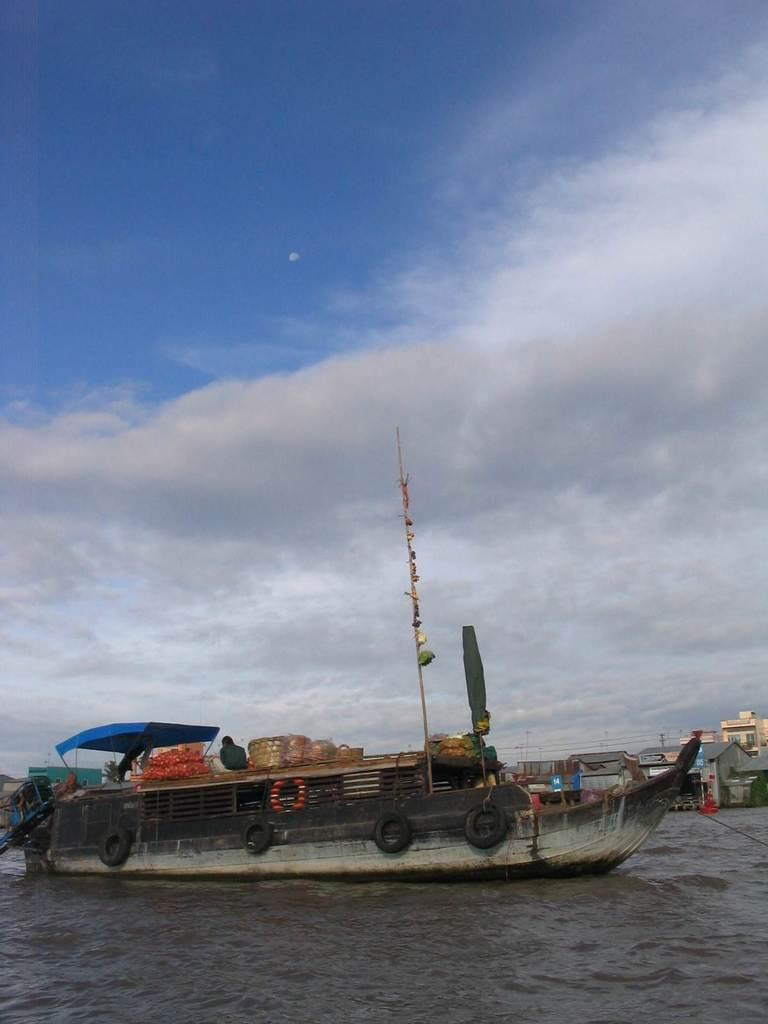What is the person in the image doing? The person is sitting on a boat in the image. Where is the boat located? The boat is on the water. What other items can be seen in the image? There is a basket, a pole, cloth, tyres, and other objects in the image. What can be seen in the background of the image? There are houses and the sky visible in the background of the image. Who is the writer of the book that the person is reading in the image? There is no book present in the image, so it is not possible to determine who the writer is. 